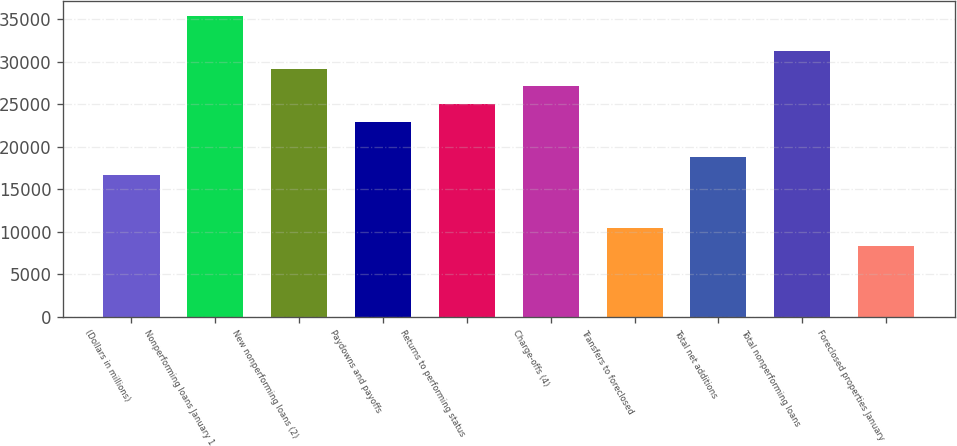Convert chart to OTSL. <chart><loc_0><loc_0><loc_500><loc_500><bar_chart><fcel>(Dollars in millions)<fcel>Nonperforming loans January 1<fcel>New nonperforming loans (2)<fcel>Paydowns and payoffs<fcel>Returns to performing status<fcel>Charge-offs (4)<fcel>Transfers to foreclosed<fcel>Total net additions<fcel>Total nonperforming loans<fcel>Foreclosed properties January<nl><fcel>16683.8<fcel>35449.6<fcel>29194.3<fcel>22939.1<fcel>25024.2<fcel>27109.3<fcel>10428.5<fcel>18768.9<fcel>31279.4<fcel>8343.45<nl></chart> 